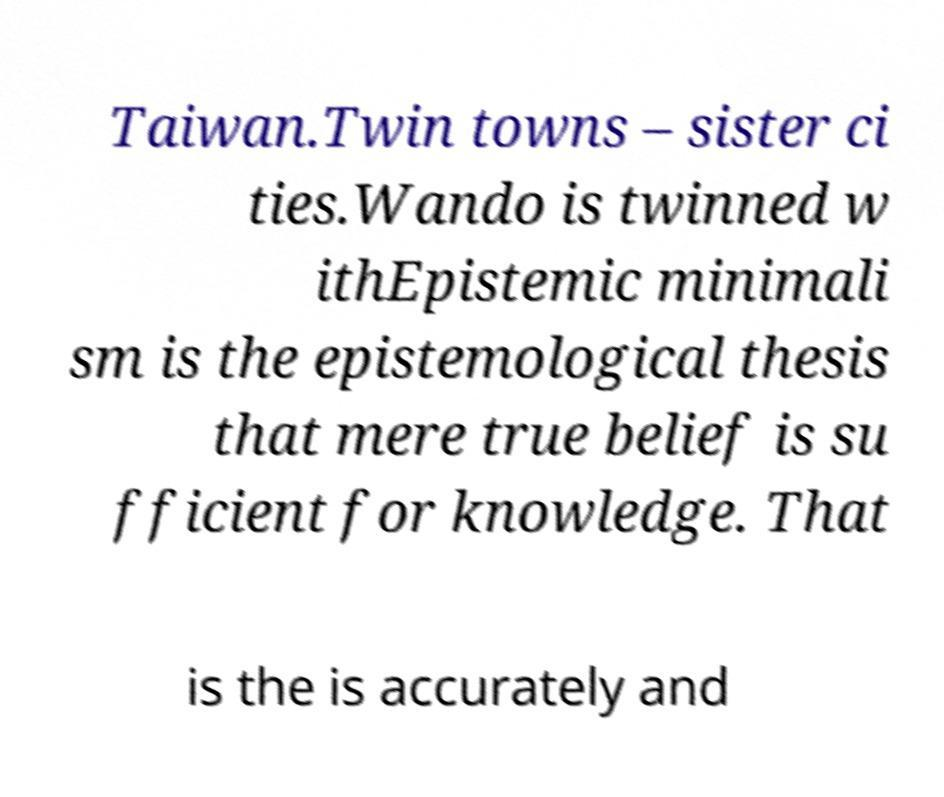Can you accurately transcribe the text from the provided image for me? Taiwan.Twin towns – sister ci ties.Wando is twinned w ithEpistemic minimali sm is the epistemological thesis that mere true belief is su fficient for knowledge. That is the is accurately and 